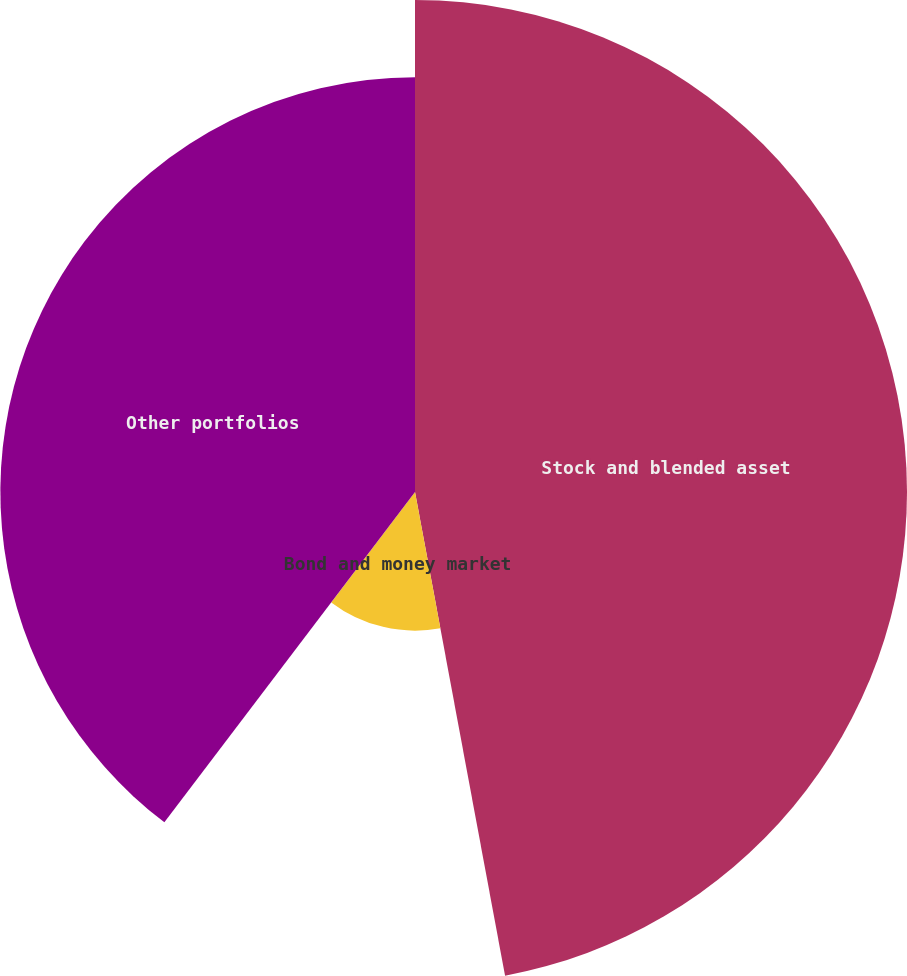<chart> <loc_0><loc_0><loc_500><loc_500><pie_chart><fcel>Stock and blended asset<fcel>Bond and money market<fcel>Other portfolios<nl><fcel>47.07%<fcel>13.26%<fcel>39.67%<nl></chart> 